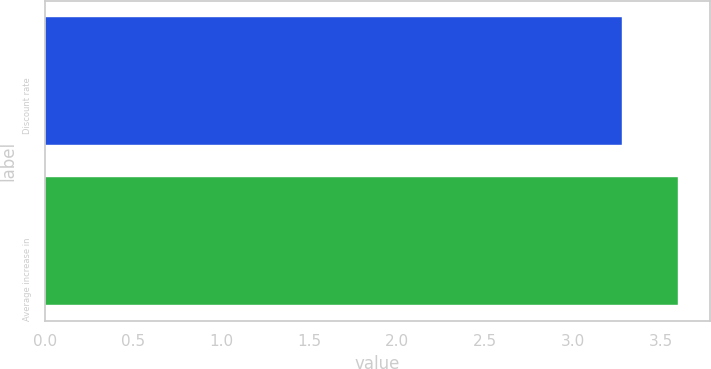<chart> <loc_0><loc_0><loc_500><loc_500><bar_chart><fcel>Discount rate<fcel>Average increase in<nl><fcel>3.28<fcel>3.6<nl></chart> 